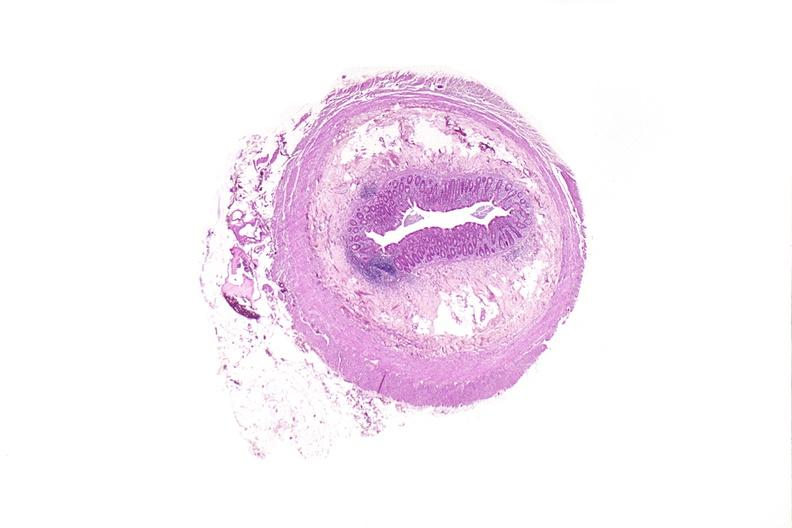what is present?
Answer the question using a single word or phrase. Gastrointestinal 